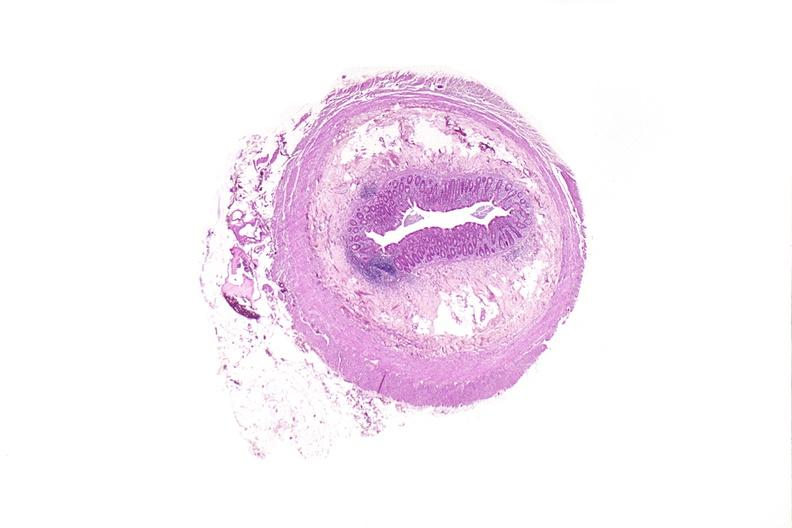what is present?
Answer the question using a single word or phrase. Gastrointestinal 